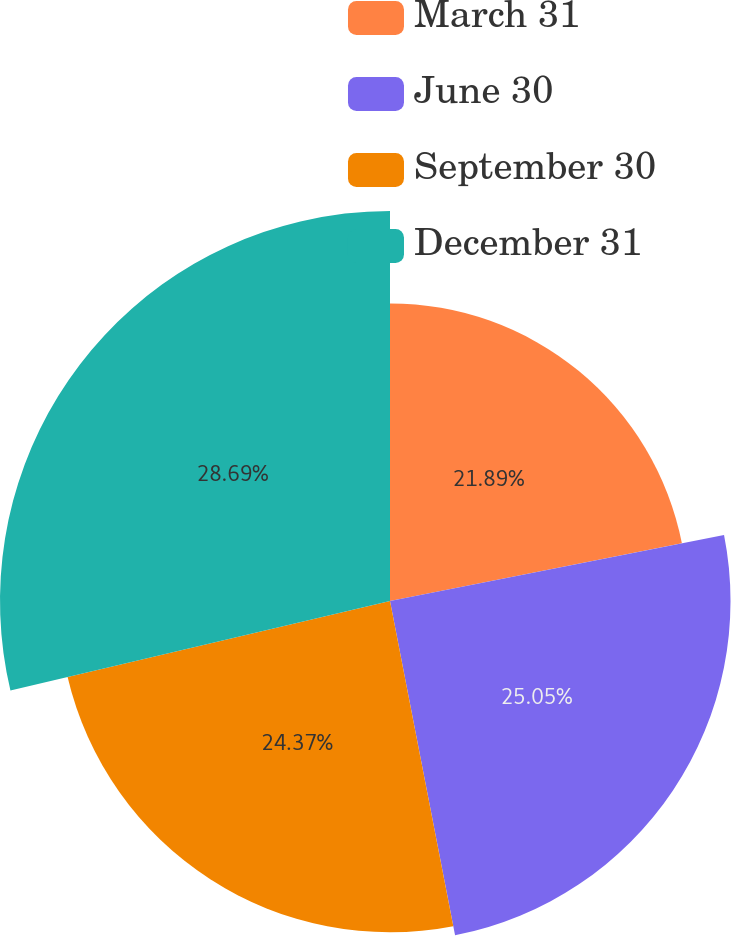Convert chart to OTSL. <chart><loc_0><loc_0><loc_500><loc_500><pie_chart><fcel>March 31<fcel>June 30<fcel>September 30<fcel>December 31<nl><fcel>21.89%<fcel>25.05%<fcel>24.37%<fcel>28.69%<nl></chart> 